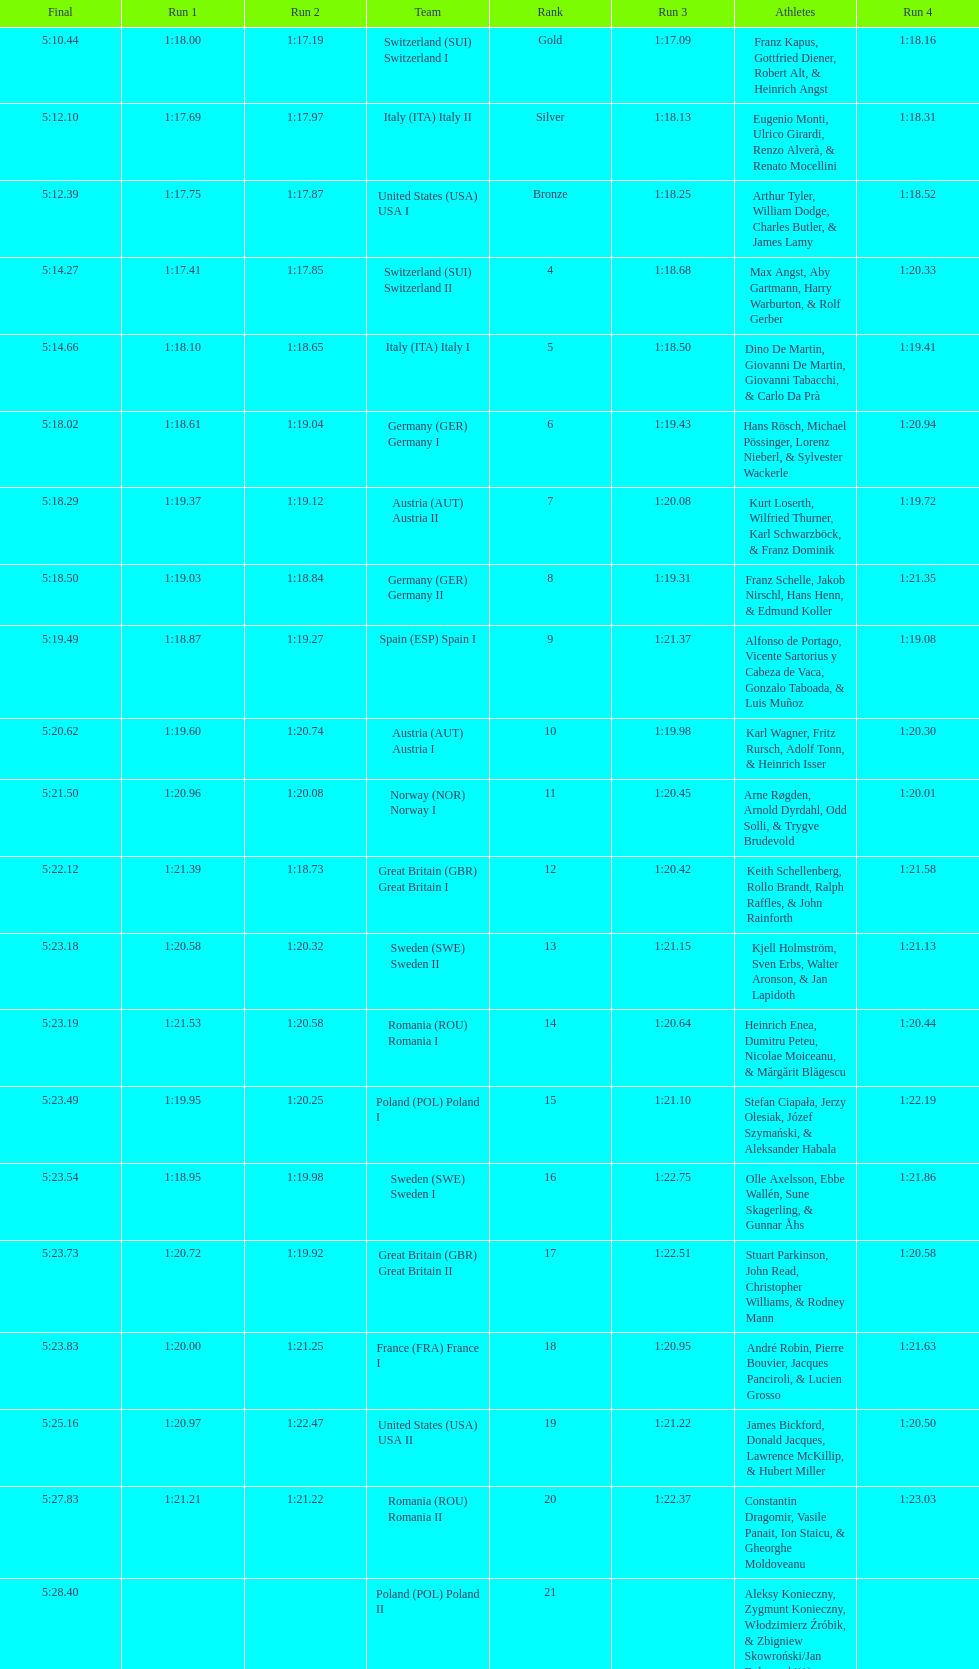Can you parse all the data within this table? {'header': ['Final', 'Run 1', 'Run 2', 'Team', 'Rank', 'Run 3', 'Athletes', 'Run 4'], 'rows': [['5:10.44', '1:18.00', '1:17.19', 'Switzerland\xa0(SUI) Switzerland I', 'Gold', '1:17.09', 'Franz Kapus, Gottfried Diener, Robert Alt, & Heinrich Angst', '1:18.16'], ['5:12.10', '1:17.69', '1:17.97', 'Italy\xa0(ITA) Italy II', 'Silver', '1:18.13', 'Eugenio Monti, Ulrico Girardi, Renzo Alverà, & Renato Mocellini', '1:18.31'], ['5:12.39', '1:17.75', '1:17.87', 'United States\xa0(USA) USA I', 'Bronze', '1:18.25', 'Arthur Tyler, William Dodge, Charles Butler, & James Lamy', '1:18.52'], ['5:14.27', '1:17.41', '1:17.85', 'Switzerland\xa0(SUI) Switzerland II', '4', '1:18.68', 'Max Angst, Aby Gartmann, Harry Warburton, & Rolf Gerber', '1:20.33'], ['5:14.66', '1:18.10', '1:18.65', 'Italy\xa0(ITA) Italy I', '5', '1:18.50', 'Dino De Martin, Giovanni De Martin, Giovanni Tabacchi, & Carlo Da Prà', '1:19.41'], ['5:18.02', '1:18.61', '1:19.04', 'Germany\xa0(GER) Germany I', '6', '1:19.43', 'Hans Rösch, Michael Pössinger, Lorenz Nieberl, & Sylvester Wackerle', '1:20.94'], ['5:18.29', '1:19.37', '1:19.12', 'Austria\xa0(AUT) Austria II', '7', '1:20.08', 'Kurt Loserth, Wilfried Thurner, Karl Schwarzböck, & Franz Dominik', '1:19.72'], ['5:18.50', '1:19.03', '1:18.84', 'Germany\xa0(GER) Germany II', '8', '1:19.31', 'Franz Schelle, Jakob Nirschl, Hans Henn, & Edmund Koller', '1:21.35'], ['5:19.49', '1:18.87', '1:19.27', 'Spain\xa0(ESP) Spain I', '9', '1:21.37', 'Alfonso de Portago, Vicente Sartorius y Cabeza de Vaca, Gonzalo Taboada, & Luis Muñoz', '1:19.08'], ['5:20.62', '1:19.60', '1:20.74', 'Austria\xa0(AUT) Austria I', '10', '1:19.98', 'Karl Wagner, Fritz Rursch, Adolf Tonn, & Heinrich Isser', '1:20.30'], ['5:21.50', '1:20.96', '1:20.08', 'Norway\xa0(NOR) Norway I', '11', '1:20.45', 'Arne Røgden, Arnold Dyrdahl, Odd Solli, & Trygve Brudevold', '1:20.01'], ['5:22.12', '1:21.39', '1:18.73', 'Great Britain\xa0(GBR) Great Britain I', '12', '1:20.42', 'Keith Schellenberg, Rollo Brandt, Ralph Raffles, & John Rainforth', '1:21.58'], ['5:23.18', '1:20.58', '1:20.32', 'Sweden\xa0(SWE) Sweden II', '13', '1:21.15', 'Kjell Holmström, Sven Erbs, Walter Aronson, & Jan Lapidoth', '1:21.13'], ['5:23.19', '1:21.53', '1:20.58', 'Romania\xa0(ROU) Romania I', '14', '1:20.64', 'Heinrich Enea, Dumitru Peteu, Nicolae Moiceanu, & Mărgărit Blăgescu', '1:20.44'], ['5:23.49', '1:19.95', '1:20.25', 'Poland\xa0(POL) Poland I', '15', '1:21.10', 'Stefan Ciapała, Jerzy Olesiak, Józef Szymański, & Aleksander Habala', '1:22.19'], ['5:23.54', '1:18.95', '1:19.98', 'Sweden\xa0(SWE) Sweden I', '16', '1:22.75', 'Olle Axelsson, Ebbe Wallén, Sune Skagerling, & Gunnar Åhs', '1:21.86'], ['5:23.73', '1:20.72', '1:19.92', 'Great Britain\xa0(GBR) Great Britain II', '17', '1:22.51', 'Stuart Parkinson, John Read, Christopher Williams, & Rodney Mann', '1:20.58'], ['5:23.83', '1:20.00', '1:21.25', 'France\xa0(FRA) France I', '18', '1:20.95', 'André Robin, Pierre Bouvier, Jacques Panciroli, & Lucien Grosso', '1:21.63'], ['5:25.16', '1:20.97', '1:22.47', 'United States\xa0(USA) USA II', '19', '1:21.22', 'James Bickford, Donald Jacques, Lawrence McKillip, & Hubert Miller', '1:20.50'], ['5:27.83', '1:21.21', '1:21.22', 'Romania\xa0(ROU) Romania II', '20', '1:22.37', 'Constantin Dragomir, Vasile Panait, Ion Staicu, & Gheorghe Moldoveanu', '1:23.03'], ['5:28.40', '', '', 'Poland\xa0(POL) Poland II', '21', '', 'Aleksy Konieczny, Zygmunt Konieczny, Włodzimierz Źróbik, & Zbigniew Skowroński/Jan Dąbrowski(*)', '']]} Which team had the most time? Poland. 